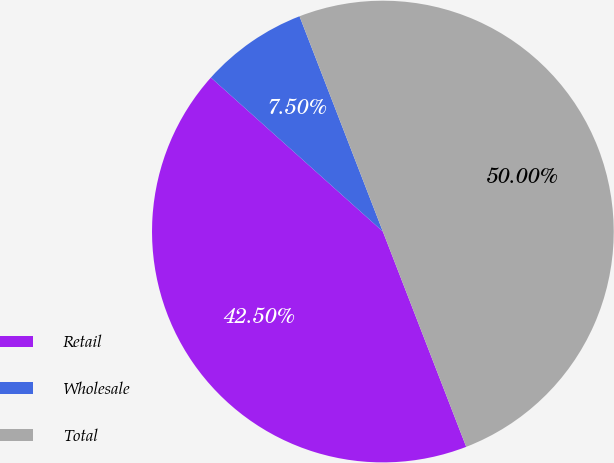Convert chart. <chart><loc_0><loc_0><loc_500><loc_500><pie_chart><fcel>Retail<fcel>Wholesale<fcel>Total<nl><fcel>42.5%<fcel>7.5%<fcel>50.0%<nl></chart> 